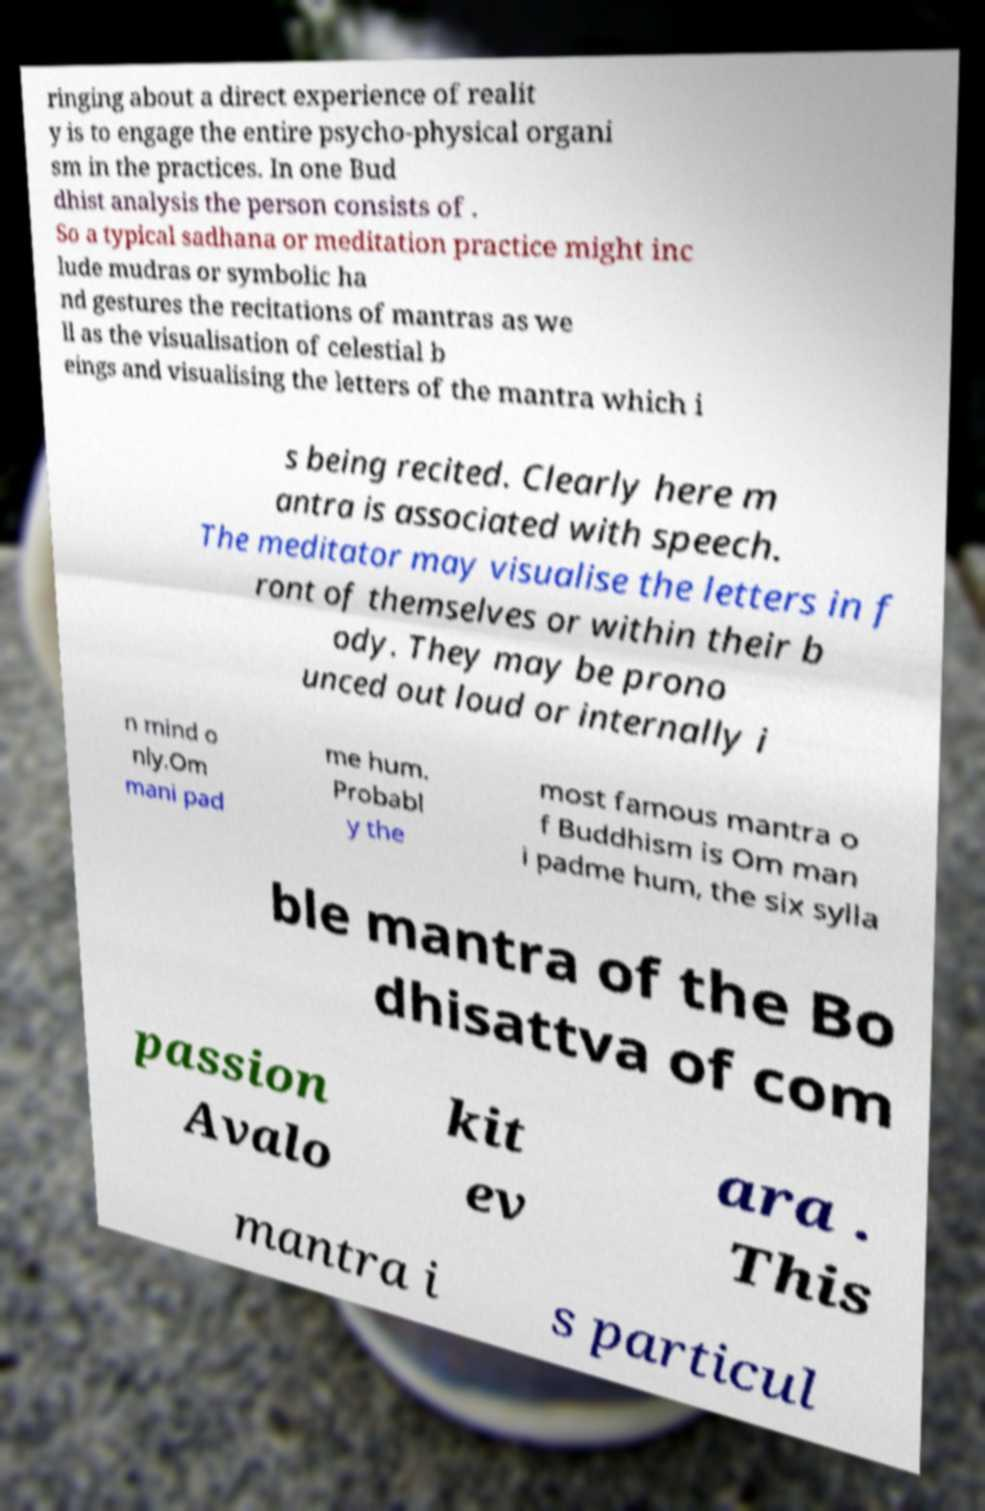What messages or text are displayed in this image? I need them in a readable, typed format. ringing about a direct experience of realit y is to engage the entire psycho-physical organi sm in the practices. In one Bud dhist analysis the person consists of . So a typical sadhana or meditation practice might inc lude mudras or symbolic ha nd gestures the recitations of mantras as we ll as the visualisation of celestial b eings and visualising the letters of the mantra which i s being recited. Clearly here m antra is associated with speech. The meditator may visualise the letters in f ront of themselves or within their b ody. They may be prono unced out loud or internally i n mind o nly.Om mani pad me hum. Probabl y the most famous mantra o f Buddhism is Om man i padme hum, the six sylla ble mantra of the Bo dhisattva of com passion Avalo kit ev ara . This mantra i s particul 